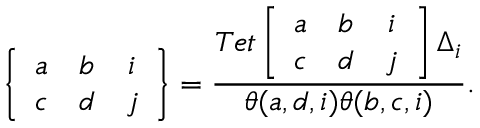Convert formula to latex. <formula><loc_0><loc_0><loc_500><loc_500>\left \{ \begin{array} { c c c } { a } & { b } & { i } \\ { c } & { d } & { j } \end{array} \right \} = \frac { T e t \left [ \begin{array} { c c c } { a } & { b } & { i } \\ { c } & { d } & { j } \end{array} \right ] \Delta _ { i } } { \theta ( a , d , i ) \theta ( b , c , i ) } .</formula> 